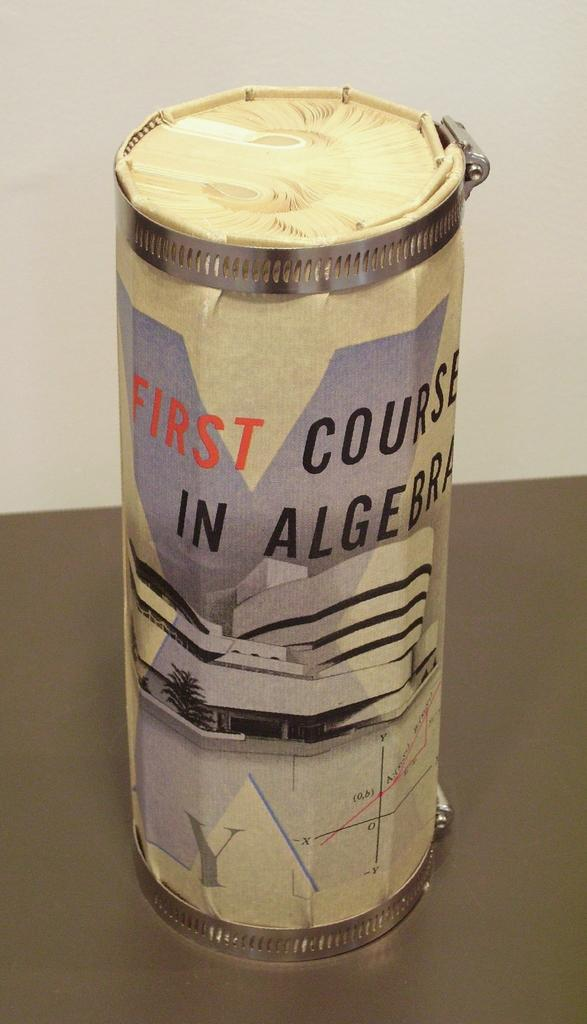<image>
Give a short and clear explanation of the subsequent image. A cylinder object has the word first on it in red. 